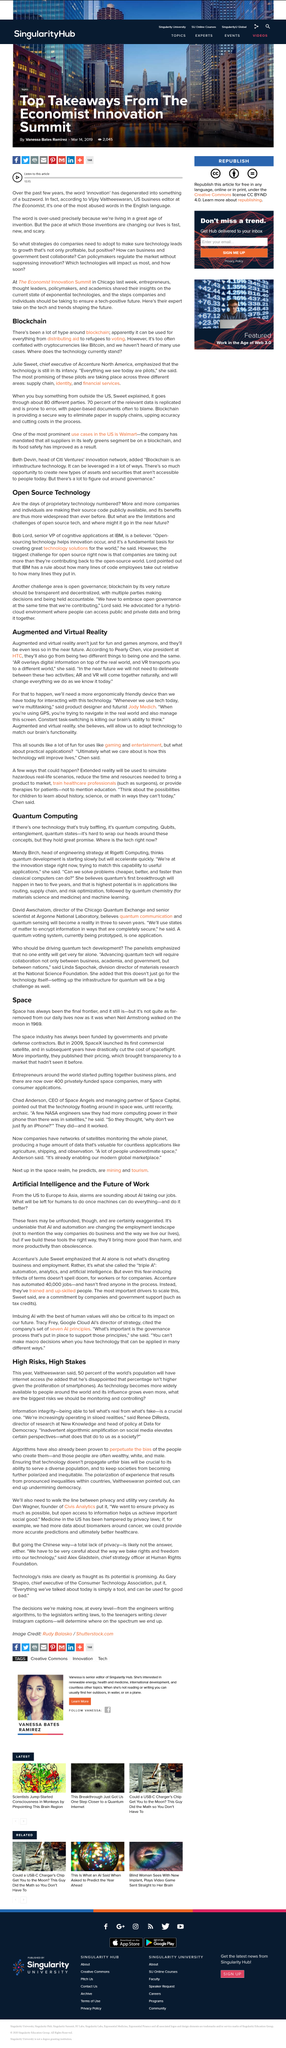Outline some significant characteristics in this image. In the past few years, the word "innovation" has degenerated into a buzzword that is commonly used but not necessarily thoroughly understood or applied in practice. Pearly Chen is the vice president at HTC. Renee DiResta is the director of research at New Knowledge and the head of policy at Data for Democracy, where she is recognized for her expertise in the field of digital research and policy. The over-use of the word 'innovation' is due to the fact that we are currently living in an era of great inventiveness. Bob Lord is the senior vice president of cognitive applications at IBM. 